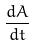Convert formula to latex. <formula><loc_0><loc_0><loc_500><loc_500>\frac { d A } { d t }</formula> 